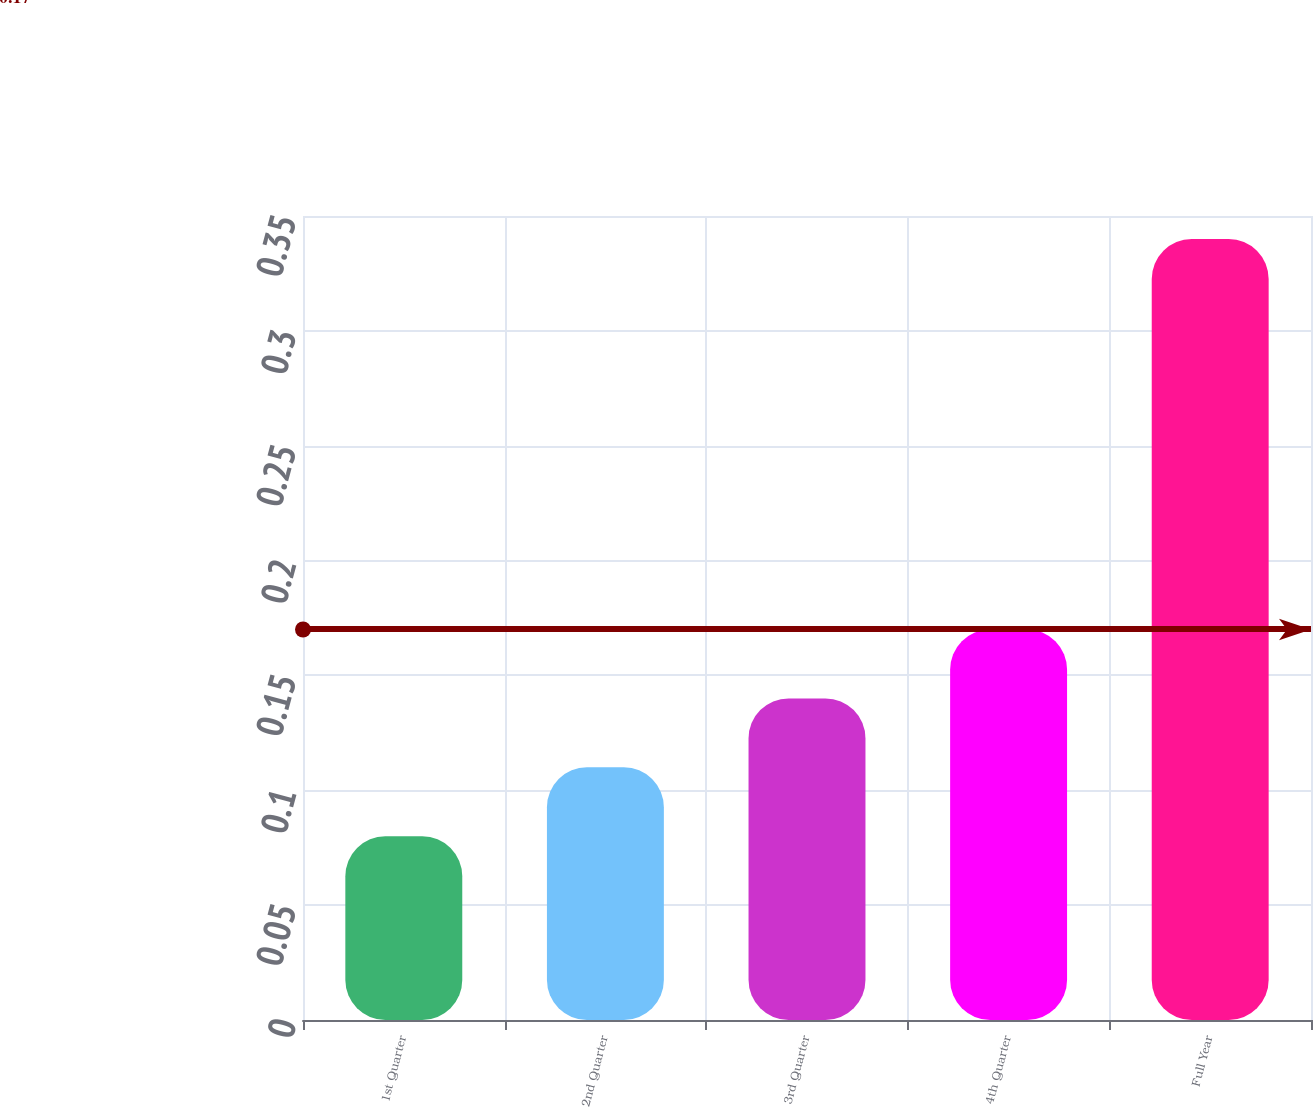Convert chart. <chart><loc_0><loc_0><loc_500><loc_500><bar_chart><fcel>1st Quarter<fcel>2nd Quarter<fcel>3rd Quarter<fcel>4th Quarter<fcel>Full Year<nl><fcel>0.08<fcel>0.11<fcel>0.14<fcel>0.17<fcel>0.34<nl></chart> 